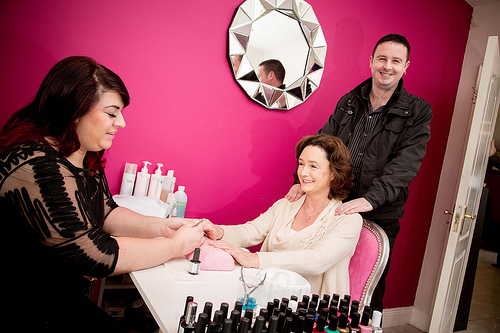<image>
Is the hands on the shoulder? Yes. Looking at the image, I can see the hands is positioned on top of the shoulder, with the shoulder providing support. Where is the man in relation to the manicure? Is it in the manicure? No. The man is not contained within the manicure. These objects have a different spatial relationship. 